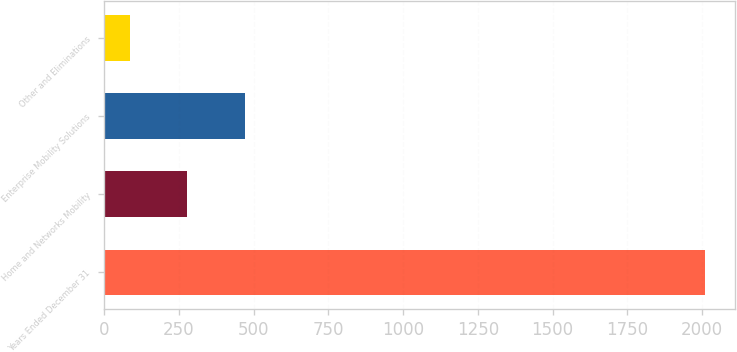Convert chart. <chart><loc_0><loc_0><loc_500><loc_500><bar_chart><fcel>Years Ended December 31<fcel>Home and Networks Mobility<fcel>Enterprise Mobility Solutions<fcel>Other and Eliminations<nl><fcel>2009<fcel>277.4<fcel>469.8<fcel>85<nl></chart> 